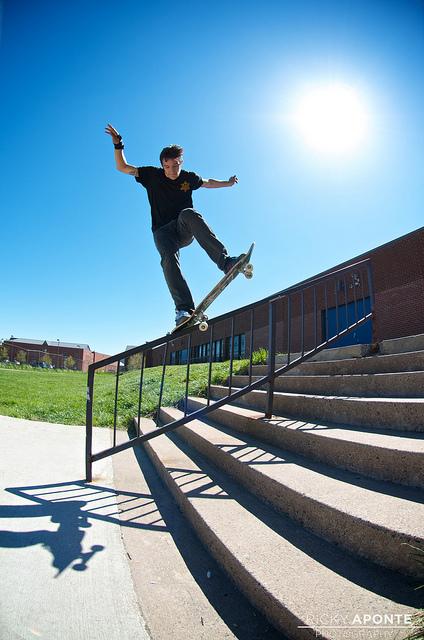Is it raining out?
Answer briefly. No. Why does this guy have his arms in that position?
Be succinct. Balance. Is the person going up or down the rail?
Short answer required. Down. 